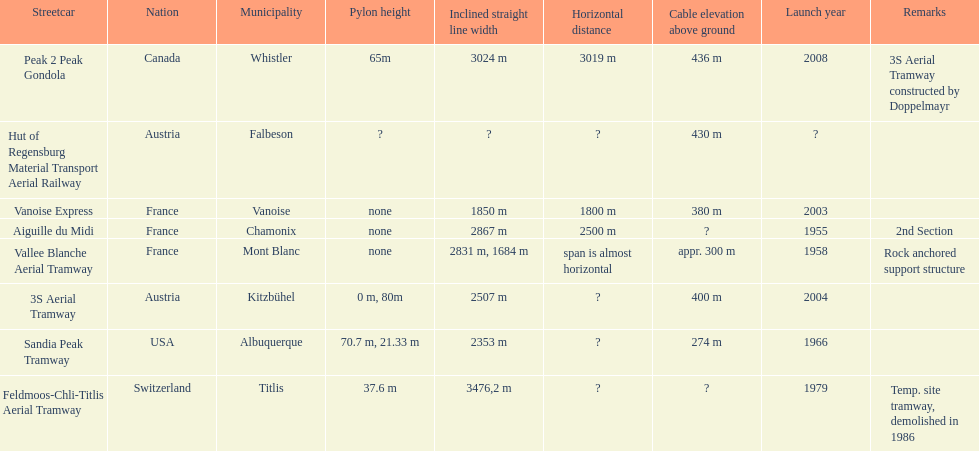Which tramway was inaugurated first, the 3s aerial tramway or the aiguille du midi? Aiguille du Midi. 